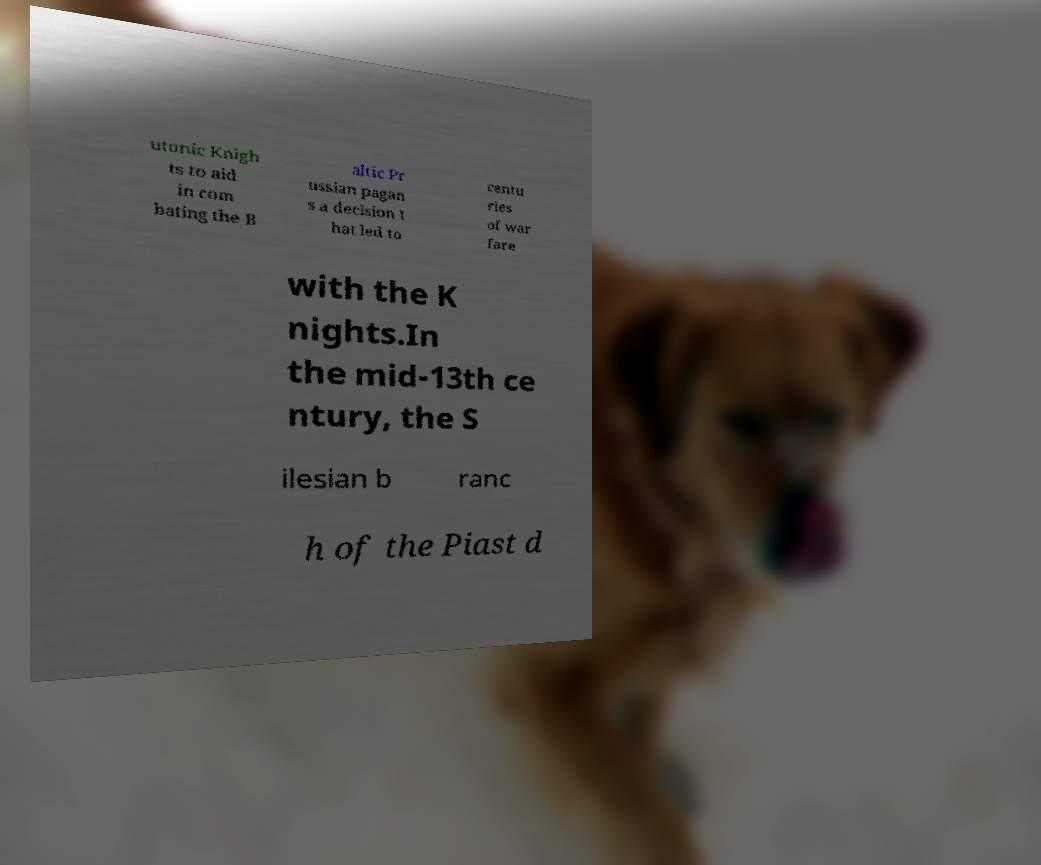There's text embedded in this image that I need extracted. Can you transcribe it verbatim? utonic Knigh ts to aid in com bating the B altic Pr ussian pagan s a decision t hat led to centu ries of war fare with the K nights.In the mid-13th ce ntury, the S ilesian b ranc h of the Piast d 